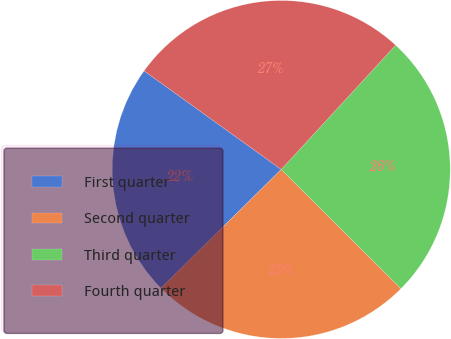<chart> <loc_0><loc_0><loc_500><loc_500><pie_chart><fcel>First quarter<fcel>Second quarter<fcel>Third quarter<fcel>Fourth quarter<nl><fcel>22.31%<fcel>25.15%<fcel>25.62%<fcel>26.92%<nl></chart> 